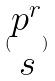<formula> <loc_0><loc_0><loc_500><loc_500>( \begin{matrix} p ^ { r } \\ s \end{matrix} )</formula> 